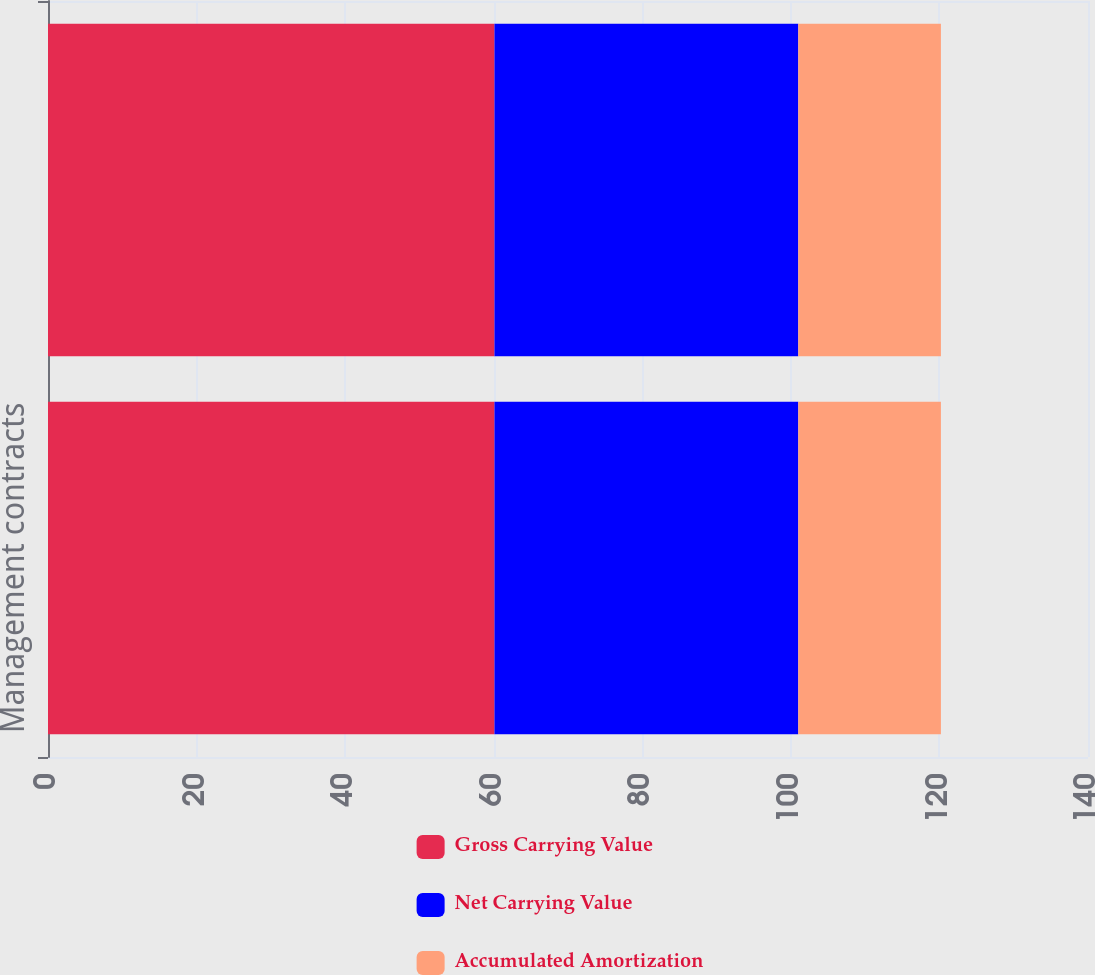<chart> <loc_0><loc_0><loc_500><loc_500><stacked_bar_chart><ecel><fcel>Management contracts<fcel>Total<nl><fcel>Gross Carrying Value<fcel>60.1<fcel>60.1<nl><fcel>Net Carrying Value<fcel>40.9<fcel>40.9<nl><fcel>Accumulated Amortization<fcel>19.2<fcel>19.2<nl></chart> 